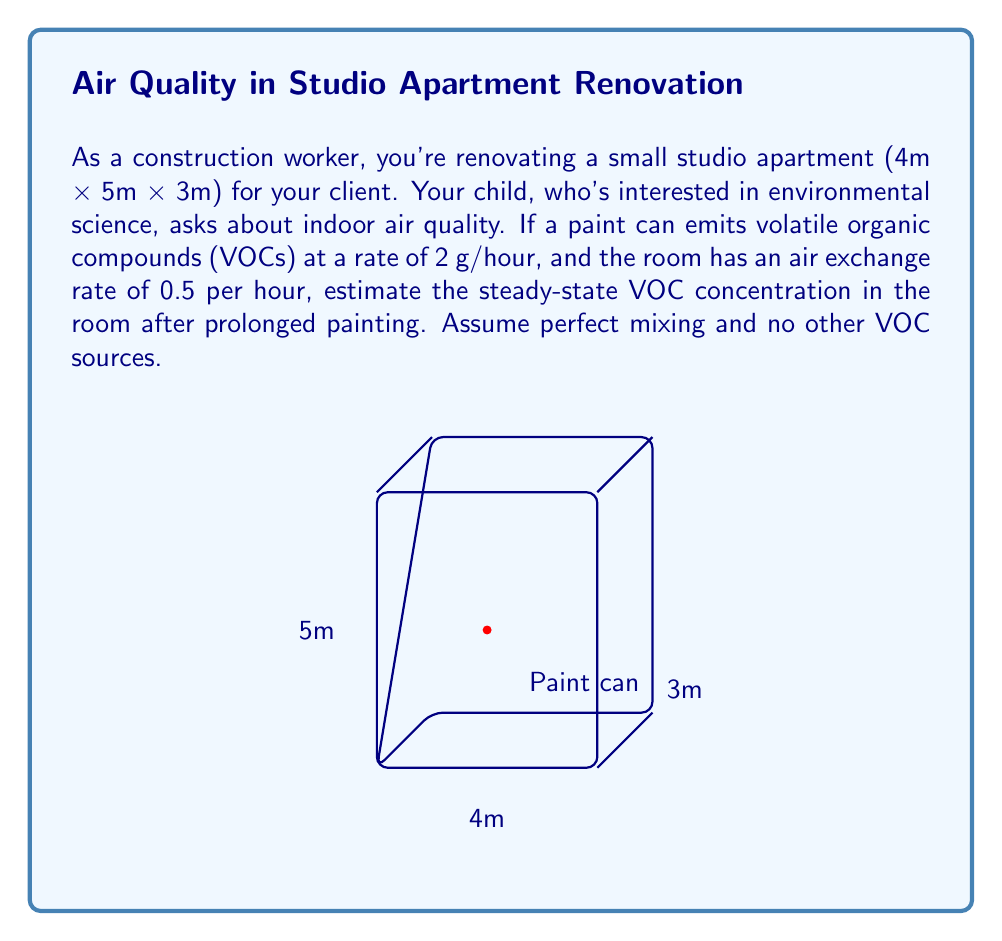Give your solution to this math problem. To solve this problem, we'll use the steady-state mass balance equation for a well-mixed room:

$$ \text{Emission rate} = \text{Removal rate} $$

Let's break it down step-by-step:

1) First, calculate the volume of the room:
   $V = 4\text{m} \times 5\text{m} \times 3\text{m} = 60\text{m}^3$

2) The emission rate is given as 2 g/hour.

3) The removal rate is the product of the air exchange rate, room volume, and concentration:
   $\text{Removal rate} = 0.5\text{h}^{-1} \times 60\text{m}^3 \times C$
   where $C$ is the steady-state concentration in g/m³.

4) Set up the mass balance equation:
   $$ 2\text{ g/h} = 0.5\text{h}^{-1} \times 60\text{m}^3 \times C\text{ g/m}^3 $$

5) Solve for C:
   $$ C = \frac{2\text{ g/h}}{0.5\text{h}^{-1} \times 60\text{m}^3} = \frac{2}{30} = \frac{1}{15}\text{ g/m}^3 $$

6) Convert to mg/m³ for a more common unit:
   $$ C = \frac{1}{15}\text{ g/m}^3 \times 1000\text{ mg/g} = 66.67\text{ mg/m}^3 $$

Therefore, the steady-state VOC concentration in the room after prolonged painting would be approximately 66.67 mg/m³.
Answer: 66.67 mg/m³ 